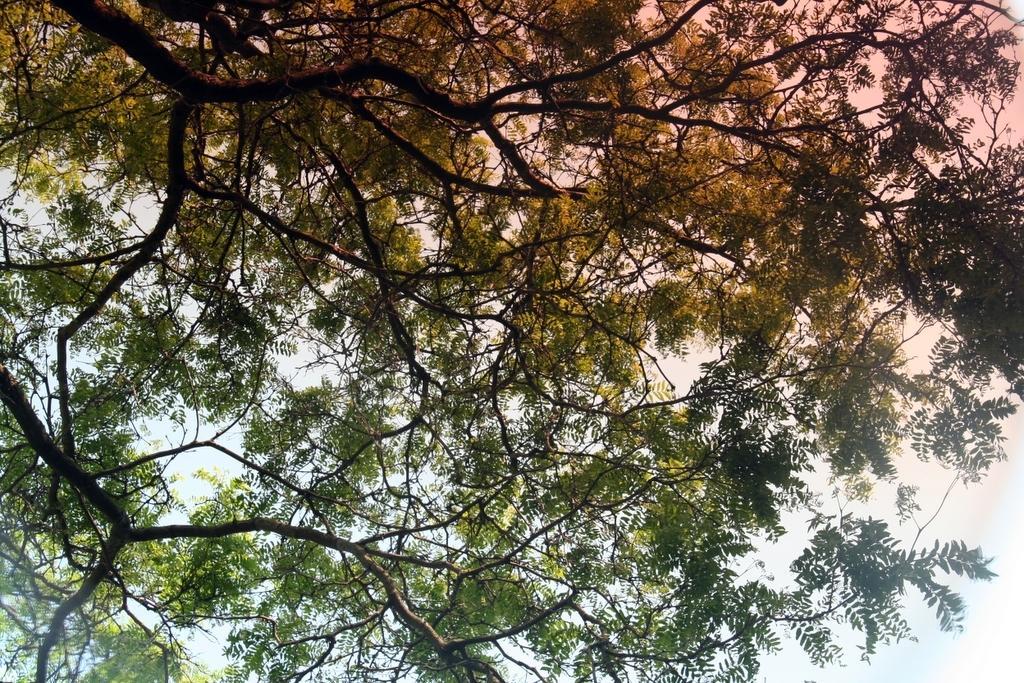In one or two sentences, can you explain what this image depicts? In this image we can see the trees and sky. 